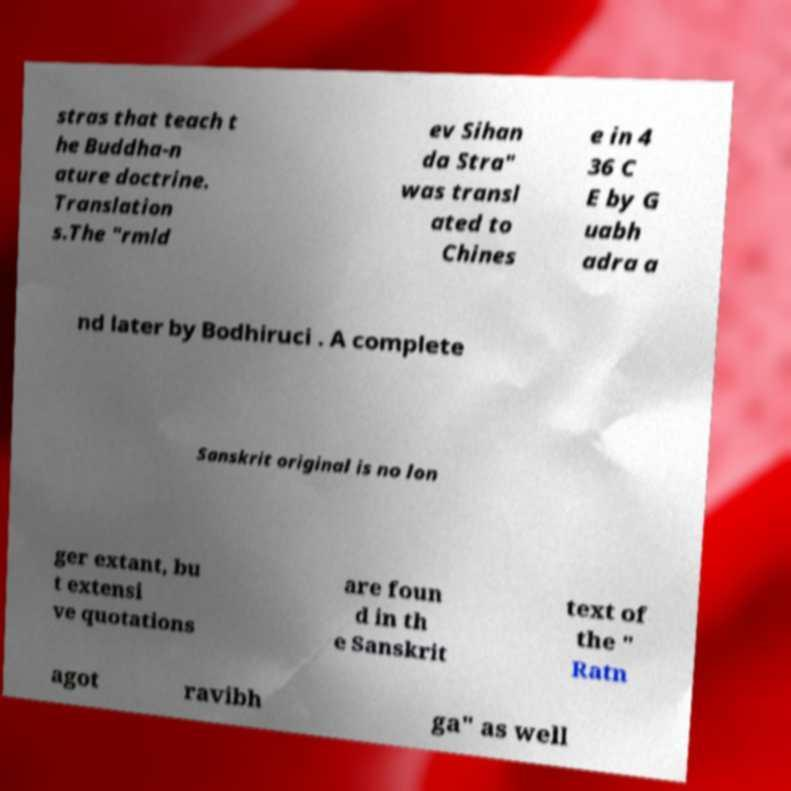There's text embedded in this image that I need extracted. Can you transcribe it verbatim? stras that teach t he Buddha-n ature doctrine. Translation s.The "rmld ev Sihan da Stra" was transl ated to Chines e in 4 36 C E by G uabh adra a nd later by Bodhiruci . A complete Sanskrit original is no lon ger extant, bu t extensi ve quotations are foun d in th e Sanskrit text of the " Ratn agot ravibh ga" as well 